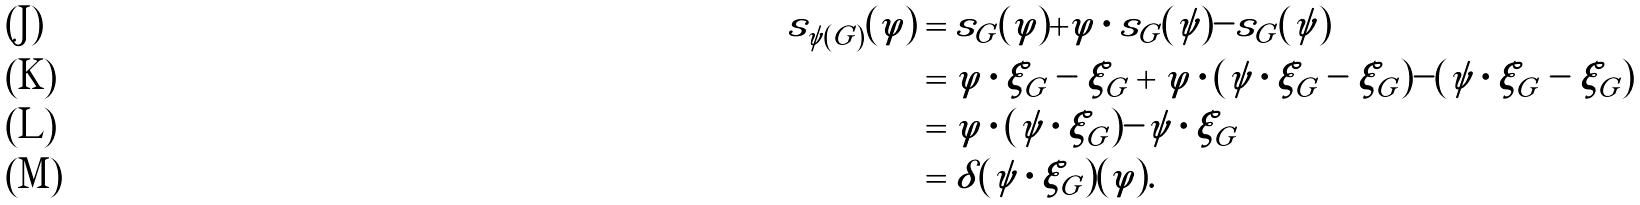<formula> <loc_0><loc_0><loc_500><loc_500>s _ { \psi ( G ) } ( \varphi ) & = s _ { G } ( \varphi ) + \varphi \cdot s _ { G } ( \psi ) - s _ { G } ( \psi ) \\ & = \varphi \cdot \xi _ { G } - \xi _ { G } + \varphi \cdot ( \psi \cdot \xi _ { G } - \xi _ { G } ) - ( \psi \cdot \xi _ { G } - \xi _ { G } ) \\ & = \varphi \cdot ( \psi \cdot \xi _ { G } ) - \psi \cdot \xi _ { G } \\ & = \delta ( \psi \cdot \xi _ { G } ) ( \varphi ) .</formula> 